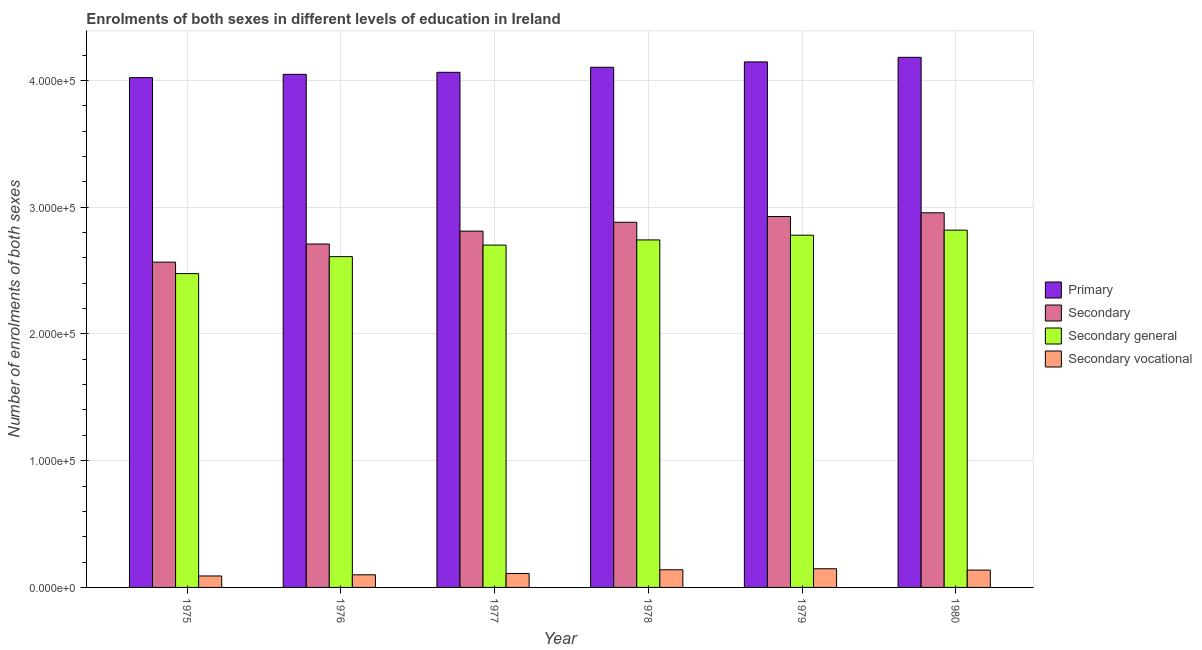Are the number of bars on each tick of the X-axis equal?
Your answer should be compact. Yes. How many bars are there on the 4th tick from the right?
Offer a very short reply. 4. What is the label of the 5th group of bars from the left?
Offer a terse response. 1979. What is the number of enrolments in secondary vocational education in 1976?
Your answer should be very brief. 9957. Across all years, what is the maximum number of enrolments in secondary general education?
Your answer should be very brief. 2.82e+05. Across all years, what is the minimum number of enrolments in secondary education?
Your response must be concise. 2.57e+05. In which year was the number of enrolments in secondary vocational education maximum?
Your answer should be compact. 1979. In which year was the number of enrolments in secondary vocational education minimum?
Give a very brief answer. 1975. What is the total number of enrolments in primary education in the graph?
Keep it short and to the point. 2.46e+06. What is the difference between the number of enrolments in secondary vocational education in 1976 and that in 1980?
Ensure brevity in your answer.  -3731. What is the difference between the number of enrolments in secondary general education in 1977 and the number of enrolments in secondary vocational education in 1980?
Make the answer very short. -1.18e+04. What is the average number of enrolments in secondary education per year?
Your answer should be compact. 2.81e+05. In how many years, is the number of enrolments in secondary general education greater than 40000?
Keep it short and to the point. 6. What is the ratio of the number of enrolments in secondary general education in 1975 to that in 1976?
Your response must be concise. 0.95. Is the number of enrolments in secondary education in 1976 less than that in 1978?
Make the answer very short. Yes. Is the difference between the number of enrolments in secondary education in 1978 and 1980 greater than the difference between the number of enrolments in secondary vocational education in 1978 and 1980?
Your answer should be compact. No. What is the difference between the highest and the second highest number of enrolments in secondary general education?
Your answer should be very brief. 3975. What is the difference between the highest and the lowest number of enrolments in secondary general education?
Make the answer very short. 3.43e+04. Is the sum of the number of enrolments in secondary education in 1975 and 1979 greater than the maximum number of enrolments in primary education across all years?
Provide a succinct answer. Yes. Is it the case that in every year, the sum of the number of enrolments in secondary vocational education and number of enrolments in primary education is greater than the sum of number of enrolments in secondary education and number of enrolments in secondary general education?
Provide a succinct answer. No. What does the 3rd bar from the left in 1980 represents?
Your response must be concise. Secondary general. What does the 4th bar from the right in 1980 represents?
Offer a terse response. Primary. Are all the bars in the graph horizontal?
Provide a short and direct response. No. What is the difference between two consecutive major ticks on the Y-axis?
Your answer should be very brief. 1.00e+05. Are the values on the major ticks of Y-axis written in scientific E-notation?
Offer a very short reply. Yes. Does the graph contain any zero values?
Keep it short and to the point. No. How are the legend labels stacked?
Keep it short and to the point. Vertical. What is the title of the graph?
Your answer should be very brief. Enrolments of both sexes in different levels of education in Ireland. What is the label or title of the Y-axis?
Keep it short and to the point. Number of enrolments of both sexes. What is the Number of enrolments of both sexes of Primary in 1975?
Give a very brief answer. 4.02e+05. What is the Number of enrolments of both sexes in Secondary in 1975?
Give a very brief answer. 2.57e+05. What is the Number of enrolments of both sexes of Secondary general in 1975?
Provide a succinct answer. 2.48e+05. What is the Number of enrolments of both sexes of Secondary vocational in 1975?
Your answer should be compact. 9043. What is the Number of enrolments of both sexes in Primary in 1976?
Ensure brevity in your answer.  4.05e+05. What is the Number of enrolments of both sexes in Secondary in 1976?
Keep it short and to the point. 2.71e+05. What is the Number of enrolments of both sexes in Secondary general in 1976?
Offer a very short reply. 2.61e+05. What is the Number of enrolments of both sexes in Secondary vocational in 1976?
Offer a very short reply. 9957. What is the Number of enrolments of both sexes of Primary in 1977?
Your answer should be very brief. 4.06e+05. What is the Number of enrolments of both sexes in Secondary in 1977?
Provide a succinct answer. 2.81e+05. What is the Number of enrolments of both sexes of Secondary general in 1977?
Your answer should be very brief. 2.70e+05. What is the Number of enrolments of both sexes in Secondary vocational in 1977?
Give a very brief answer. 1.10e+04. What is the Number of enrolments of both sexes of Primary in 1978?
Offer a terse response. 4.10e+05. What is the Number of enrolments of both sexes of Secondary in 1978?
Offer a terse response. 2.88e+05. What is the Number of enrolments of both sexes in Secondary general in 1978?
Make the answer very short. 2.74e+05. What is the Number of enrolments of both sexes of Secondary vocational in 1978?
Give a very brief answer. 1.39e+04. What is the Number of enrolments of both sexes of Primary in 1979?
Ensure brevity in your answer.  4.15e+05. What is the Number of enrolments of both sexes in Secondary in 1979?
Ensure brevity in your answer.  2.93e+05. What is the Number of enrolments of both sexes in Secondary general in 1979?
Offer a terse response. 2.78e+05. What is the Number of enrolments of both sexes of Secondary vocational in 1979?
Ensure brevity in your answer.  1.47e+04. What is the Number of enrolments of both sexes in Primary in 1980?
Offer a very short reply. 4.18e+05. What is the Number of enrolments of both sexes of Secondary in 1980?
Ensure brevity in your answer.  2.96e+05. What is the Number of enrolments of both sexes in Secondary general in 1980?
Your response must be concise. 2.82e+05. What is the Number of enrolments of both sexes in Secondary vocational in 1980?
Your response must be concise. 1.37e+04. Across all years, what is the maximum Number of enrolments of both sexes of Primary?
Your response must be concise. 4.18e+05. Across all years, what is the maximum Number of enrolments of both sexes in Secondary?
Give a very brief answer. 2.96e+05. Across all years, what is the maximum Number of enrolments of both sexes of Secondary general?
Give a very brief answer. 2.82e+05. Across all years, what is the maximum Number of enrolments of both sexes in Secondary vocational?
Ensure brevity in your answer.  1.47e+04. Across all years, what is the minimum Number of enrolments of both sexes in Primary?
Offer a very short reply. 4.02e+05. Across all years, what is the minimum Number of enrolments of both sexes of Secondary?
Provide a short and direct response. 2.57e+05. Across all years, what is the minimum Number of enrolments of both sexes in Secondary general?
Offer a terse response. 2.48e+05. Across all years, what is the minimum Number of enrolments of both sexes of Secondary vocational?
Your answer should be very brief. 9043. What is the total Number of enrolments of both sexes in Primary in the graph?
Your answer should be very brief. 2.46e+06. What is the total Number of enrolments of both sexes of Secondary in the graph?
Keep it short and to the point. 1.69e+06. What is the total Number of enrolments of both sexes of Secondary general in the graph?
Make the answer very short. 1.61e+06. What is the total Number of enrolments of both sexes in Secondary vocational in the graph?
Make the answer very short. 7.24e+04. What is the difference between the Number of enrolments of both sexes of Primary in 1975 and that in 1976?
Provide a short and direct response. -2599. What is the difference between the Number of enrolments of both sexes of Secondary in 1975 and that in 1976?
Provide a succinct answer. -1.43e+04. What is the difference between the Number of enrolments of both sexes in Secondary general in 1975 and that in 1976?
Keep it short and to the point. -1.34e+04. What is the difference between the Number of enrolments of both sexes of Secondary vocational in 1975 and that in 1976?
Offer a very short reply. -914. What is the difference between the Number of enrolments of both sexes of Primary in 1975 and that in 1977?
Your answer should be compact. -4213. What is the difference between the Number of enrolments of both sexes in Secondary in 1975 and that in 1977?
Provide a short and direct response. -2.45e+04. What is the difference between the Number of enrolments of both sexes of Secondary general in 1975 and that in 1977?
Keep it short and to the point. -2.25e+04. What is the difference between the Number of enrolments of both sexes in Secondary vocational in 1975 and that in 1977?
Provide a short and direct response. -1972. What is the difference between the Number of enrolments of both sexes of Primary in 1975 and that in 1978?
Make the answer very short. -8183. What is the difference between the Number of enrolments of both sexes of Secondary in 1975 and that in 1978?
Provide a short and direct response. -3.15e+04. What is the difference between the Number of enrolments of both sexes of Secondary general in 1975 and that in 1978?
Ensure brevity in your answer.  -2.66e+04. What is the difference between the Number of enrolments of both sexes in Secondary vocational in 1975 and that in 1978?
Your answer should be compact. -4879. What is the difference between the Number of enrolments of both sexes in Primary in 1975 and that in 1979?
Offer a very short reply. -1.24e+04. What is the difference between the Number of enrolments of both sexes in Secondary in 1975 and that in 1979?
Provide a short and direct response. -3.60e+04. What is the difference between the Number of enrolments of both sexes of Secondary general in 1975 and that in 1979?
Make the answer very short. -3.03e+04. What is the difference between the Number of enrolments of both sexes in Secondary vocational in 1975 and that in 1979?
Offer a terse response. -5686. What is the difference between the Number of enrolments of both sexes of Primary in 1975 and that in 1980?
Offer a very short reply. -1.60e+04. What is the difference between the Number of enrolments of both sexes in Secondary in 1975 and that in 1980?
Provide a succinct answer. -3.89e+04. What is the difference between the Number of enrolments of both sexes in Secondary general in 1975 and that in 1980?
Your answer should be compact. -3.43e+04. What is the difference between the Number of enrolments of both sexes in Secondary vocational in 1975 and that in 1980?
Ensure brevity in your answer.  -4645. What is the difference between the Number of enrolments of both sexes of Primary in 1976 and that in 1977?
Your answer should be very brief. -1614. What is the difference between the Number of enrolments of both sexes of Secondary in 1976 and that in 1977?
Provide a short and direct response. -1.02e+04. What is the difference between the Number of enrolments of both sexes in Secondary general in 1976 and that in 1977?
Give a very brief answer. -9107. What is the difference between the Number of enrolments of both sexes in Secondary vocational in 1976 and that in 1977?
Your answer should be compact. -1058. What is the difference between the Number of enrolments of both sexes in Primary in 1976 and that in 1978?
Your answer should be very brief. -5584. What is the difference between the Number of enrolments of both sexes in Secondary in 1976 and that in 1978?
Make the answer very short. -1.72e+04. What is the difference between the Number of enrolments of both sexes in Secondary general in 1976 and that in 1978?
Keep it short and to the point. -1.32e+04. What is the difference between the Number of enrolments of both sexes of Secondary vocational in 1976 and that in 1978?
Provide a short and direct response. -3965. What is the difference between the Number of enrolments of both sexes of Primary in 1976 and that in 1979?
Offer a very short reply. -9806. What is the difference between the Number of enrolments of both sexes in Secondary in 1976 and that in 1979?
Provide a succinct answer. -2.17e+04. What is the difference between the Number of enrolments of both sexes of Secondary general in 1976 and that in 1979?
Your answer should be very brief. -1.69e+04. What is the difference between the Number of enrolments of both sexes in Secondary vocational in 1976 and that in 1979?
Offer a terse response. -4772. What is the difference between the Number of enrolments of both sexes of Primary in 1976 and that in 1980?
Provide a succinct answer. -1.34e+04. What is the difference between the Number of enrolments of both sexes of Secondary in 1976 and that in 1980?
Provide a short and direct response. -2.46e+04. What is the difference between the Number of enrolments of both sexes of Secondary general in 1976 and that in 1980?
Your response must be concise. -2.09e+04. What is the difference between the Number of enrolments of both sexes of Secondary vocational in 1976 and that in 1980?
Your answer should be compact. -3731. What is the difference between the Number of enrolments of both sexes of Primary in 1977 and that in 1978?
Your response must be concise. -3970. What is the difference between the Number of enrolments of both sexes of Secondary in 1977 and that in 1978?
Offer a very short reply. -6989. What is the difference between the Number of enrolments of both sexes in Secondary general in 1977 and that in 1978?
Your answer should be compact. -4082. What is the difference between the Number of enrolments of both sexes of Secondary vocational in 1977 and that in 1978?
Ensure brevity in your answer.  -2907. What is the difference between the Number of enrolments of both sexes of Primary in 1977 and that in 1979?
Your answer should be compact. -8192. What is the difference between the Number of enrolments of both sexes of Secondary in 1977 and that in 1979?
Provide a succinct answer. -1.15e+04. What is the difference between the Number of enrolments of both sexes in Secondary general in 1977 and that in 1979?
Make the answer very short. -7823. What is the difference between the Number of enrolments of both sexes of Secondary vocational in 1977 and that in 1979?
Make the answer very short. -3714. What is the difference between the Number of enrolments of both sexes of Primary in 1977 and that in 1980?
Offer a terse response. -1.18e+04. What is the difference between the Number of enrolments of both sexes of Secondary in 1977 and that in 1980?
Keep it short and to the point. -1.45e+04. What is the difference between the Number of enrolments of both sexes of Secondary general in 1977 and that in 1980?
Your response must be concise. -1.18e+04. What is the difference between the Number of enrolments of both sexes in Secondary vocational in 1977 and that in 1980?
Provide a succinct answer. -2673. What is the difference between the Number of enrolments of both sexes of Primary in 1978 and that in 1979?
Ensure brevity in your answer.  -4222. What is the difference between the Number of enrolments of both sexes in Secondary in 1978 and that in 1979?
Make the answer very short. -4548. What is the difference between the Number of enrolments of both sexes of Secondary general in 1978 and that in 1979?
Your answer should be compact. -3741. What is the difference between the Number of enrolments of both sexes of Secondary vocational in 1978 and that in 1979?
Your response must be concise. -807. What is the difference between the Number of enrolments of both sexes in Primary in 1978 and that in 1980?
Offer a very short reply. -7845. What is the difference between the Number of enrolments of both sexes of Secondary in 1978 and that in 1980?
Provide a short and direct response. -7482. What is the difference between the Number of enrolments of both sexes in Secondary general in 1978 and that in 1980?
Offer a very short reply. -7716. What is the difference between the Number of enrolments of both sexes in Secondary vocational in 1978 and that in 1980?
Offer a terse response. 234. What is the difference between the Number of enrolments of both sexes of Primary in 1979 and that in 1980?
Offer a very short reply. -3623. What is the difference between the Number of enrolments of both sexes of Secondary in 1979 and that in 1980?
Your response must be concise. -2934. What is the difference between the Number of enrolments of both sexes in Secondary general in 1979 and that in 1980?
Keep it short and to the point. -3975. What is the difference between the Number of enrolments of both sexes in Secondary vocational in 1979 and that in 1980?
Provide a succinct answer. 1041. What is the difference between the Number of enrolments of both sexes in Primary in 1975 and the Number of enrolments of both sexes in Secondary in 1976?
Provide a succinct answer. 1.31e+05. What is the difference between the Number of enrolments of both sexes of Primary in 1975 and the Number of enrolments of both sexes of Secondary general in 1976?
Your answer should be compact. 1.41e+05. What is the difference between the Number of enrolments of both sexes of Primary in 1975 and the Number of enrolments of both sexes of Secondary vocational in 1976?
Your answer should be very brief. 3.92e+05. What is the difference between the Number of enrolments of both sexes of Secondary in 1975 and the Number of enrolments of both sexes of Secondary general in 1976?
Give a very brief answer. -4347. What is the difference between the Number of enrolments of both sexes in Secondary in 1975 and the Number of enrolments of both sexes in Secondary vocational in 1976?
Provide a short and direct response. 2.47e+05. What is the difference between the Number of enrolments of both sexes of Secondary general in 1975 and the Number of enrolments of both sexes of Secondary vocational in 1976?
Ensure brevity in your answer.  2.38e+05. What is the difference between the Number of enrolments of both sexes in Primary in 1975 and the Number of enrolments of both sexes in Secondary in 1977?
Give a very brief answer. 1.21e+05. What is the difference between the Number of enrolments of both sexes of Primary in 1975 and the Number of enrolments of both sexes of Secondary general in 1977?
Ensure brevity in your answer.  1.32e+05. What is the difference between the Number of enrolments of both sexes of Primary in 1975 and the Number of enrolments of both sexes of Secondary vocational in 1977?
Ensure brevity in your answer.  3.91e+05. What is the difference between the Number of enrolments of both sexes in Secondary in 1975 and the Number of enrolments of both sexes in Secondary general in 1977?
Give a very brief answer. -1.35e+04. What is the difference between the Number of enrolments of both sexes of Secondary in 1975 and the Number of enrolments of both sexes of Secondary vocational in 1977?
Your answer should be compact. 2.46e+05. What is the difference between the Number of enrolments of both sexes of Secondary general in 1975 and the Number of enrolments of both sexes of Secondary vocational in 1977?
Your answer should be very brief. 2.37e+05. What is the difference between the Number of enrolments of both sexes in Primary in 1975 and the Number of enrolments of both sexes in Secondary in 1978?
Give a very brief answer. 1.14e+05. What is the difference between the Number of enrolments of both sexes of Primary in 1975 and the Number of enrolments of both sexes of Secondary general in 1978?
Give a very brief answer. 1.28e+05. What is the difference between the Number of enrolments of both sexes of Primary in 1975 and the Number of enrolments of both sexes of Secondary vocational in 1978?
Make the answer very short. 3.88e+05. What is the difference between the Number of enrolments of both sexes of Secondary in 1975 and the Number of enrolments of both sexes of Secondary general in 1978?
Give a very brief answer. -1.75e+04. What is the difference between the Number of enrolments of both sexes of Secondary in 1975 and the Number of enrolments of both sexes of Secondary vocational in 1978?
Provide a succinct answer. 2.43e+05. What is the difference between the Number of enrolments of both sexes of Secondary general in 1975 and the Number of enrolments of both sexes of Secondary vocational in 1978?
Provide a succinct answer. 2.34e+05. What is the difference between the Number of enrolments of both sexes in Primary in 1975 and the Number of enrolments of both sexes in Secondary in 1979?
Your answer should be very brief. 1.10e+05. What is the difference between the Number of enrolments of both sexes of Primary in 1975 and the Number of enrolments of both sexes of Secondary general in 1979?
Your response must be concise. 1.24e+05. What is the difference between the Number of enrolments of both sexes of Primary in 1975 and the Number of enrolments of both sexes of Secondary vocational in 1979?
Provide a short and direct response. 3.87e+05. What is the difference between the Number of enrolments of both sexes of Secondary in 1975 and the Number of enrolments of both sexes of Secondary general in 1979?
Offer a terse response. -2.13e+04. What is the difference between the Number of enrolments of both sexes in Secondary in 1975 and the Number of enrolments of both sexes in Secondary vocational in 1979?
Provide a short and direct response. 2.42e+05. What is the difference between the Number of enrolments of both sexes in Secondary general in 1975 and the Number of enrolments of both sexes in Secondary vocational in 1979?
Ensure brevity in your answer.  2.33e+05. What is the difference between the Number of enrolments of both sexes of Primary in 1975 and the Number of enrolments of both sexes of Secondary in 1980?
Offer a terse response. 1.07e+05. What is the difference between the Number of enrolments of both sexes of Primary in 1975 and the Number of enrolments of both sexes of Secondary general in 1980?
Offer a terse response. 1.20e+05. What is the difference between the Number of enrolments of both sexes of Primary in 1975 and the Number of enrolments of both sexes of Secondary vocational in 1980?
Make the answer very short. 3.89e+05. What is the difference between the Number of enrolments of both sexes in Secondary in 1975 and the Number of enrolments of both sexes in Secondary general in 1980?
Ensure brevity in your answer.  -2.53e+04. What is the difference between the Number of enrolments of both sexes of Secondary in 1975 and the Number of enrolments of both sexes of Secondary vocational in 1980?
Keep it short and to the point. 2.43e+05. What is the difference between the Number of enrolments of both sexes in Secondary general in 1975 and the Number of enrolments of both sexes in Secondary vocational in 1980?
Provide a succinct answer. 2.34e+05. What is the difference between the Number of enrolments of both sexes of Primary in 1976 and the Number of enrolments of both sexes of Secondary in 1977?
Give a very brief answer. 1.24e+05. What is the difference between the Number of enrolments of both sexes in Primary in 1976 and the Number of enrolments of both sexes in Secondary general in 1977?
Offer a terse response. 1.35e+05. What is the difference between the Number of enrolments of both sexes in Primary in 1976 and the Number of enrolments of both sexes in Secondary vocational in 1977?
Keep it short and to the point. 3.94e+05. What is the difference between the Number of enrolments of both sexes of Secondary in 1976 and the Number of enrolments of both sexes of Secondary general in 1977?
Your answer should be very brief. 850. What is the difference between the Number of enrolments of both sexes of Secondary in 1976 and the Number of enrolments of both sexes of Secondary vocational in 1977?
Provide a short and direct response. 2.60e+05. What is the difference between the Number of enrolments of both sexes of Secondary general in 1976 and the Number of enrolments of both sexes of Secondary vocational in 1977?
Your answer should be very brief. 2.50e+05. What is the difference between the Number of enrolments of both sexes of Primary in 1976 and the Number of enrolments of both sexes of Secondary in 1978?
Your answer should be compact. 1.17e+05. What is the difference between the Number of enrolments of both sexes in Primary in 1976 and the Number of enrolments of both sexes in Secondary general in 1978?
Provide a short and direct response. 1.31e+05. What is the difference between the Number of enrolments of both sexes in Primary in 1976 and the Number of enrolments of both sexes in Secondary vocational in 1978?
Offer a terse response. 3.91e+05. What is the difference between the Number of enrolments of both sexes of Secondary in 1976 and the Number of enrolments of both sexes of Secondary general in 1978?
Your response must be concise. -3232. What is the difference between the Number of enrolments of both sexes of Secondary in 1976 and the Number of enrolments of both sexes of Secondary vocational in 1978?
Offer a terse response. 2.57e+05. What is the difference between the Number of enrolments of both sexes in Secondary general in 1976 and the Number of enrolments of both sexes in Secondary vocational in 1978?
Provide a succinct answer. 2.47e+05. What is the difference between the Number of enrolments of both sexes of Primary in 1976 and the Number of enrolments of both sexes of Secondary in 1979?
Ensure brevity in your answer.  1.12e+05. What is the difference between the Number of enrolments of both sexes in Primary in 1976 and the Number of enrolments of both sexes in Secondary general in 1979?
Your answer should be compact. 1.27e+05. What is the difference between the Number of enrolments of both sexes of Primary in 1976 and the Number of enrolments of both sexes of Secondary vocational in 1979?
Offer a very short reply. 3.90e+05. What is the difference between the Number of enrolments of both sexes of Secondary in 1976 and the Number of enrolments of both sexes of Secondary general in 1979?
Give a very brief answer. -6973. What is the difference between the Number of enrolments of both sexes in Secondary in 1976 and the Number of enrolments of both sexes in Secondary vocational in 1979?
Your answer should be very brief. 2.56e+05. What is the difference between the Number of enrolments of both sexes in Secondary general in 1976 and the Number of enrolments of both sexes in Secondary vocational in 1979?
Your answer should be compact. 2.46e+05. What is the difference between the Number of enrolments of both sexes in Primary in 1976 and the Number of enrolments of both sexes in Secondary in 1980?
Your answer should be compact. 1.09e+05. What is the difference between the Number of enrolments of both sexes of Primary in 1976 and the Number of enrolments of both sexes of Secondary general in 1980?
Offer a very short reply. 1.23e+05. What is the difference between the Number of enrolments of both sexes of Primary in 1976 and the Number of enrolments of both sexes of Secondary vocational in 1980?
Offer a terse response. 3.91e+05. What is the difference between the Number of enrolments of both sexes of Secondary in 1976 and the Number of enrolments of both sexes of Secondary general in 1980?
Keep it short and to the point. -1.09e+04. What is the difference between the Number of enrolments of both sexes of Secondary in 1976 and the Number of enrolments of both sexes of Secondary vocational in 1980?
Your answer should be very brief. 2.57e+05. What is the difference between the Number of enrolments of both sexes of Secondary general in 1976 and the Number of enrolments of both sexes of Secondary vocational in 1980?
Offer a very short reply. 2.47e+05. What is the difference between the Number of enrolments of both sexes of Primary in 1977 and the Number of enrolments of both sexes of Secondary in 1978?
Provide a succinct answer. 1.18e+05. What is the difference between the Number of enrolments of both sexes of Primary in 1977 and the Number of enrolments of both sexes of Secondary general in 1978?
Make the answer very short. 1.32e+05. What is the difference between the Number of enrolments of both sexes of Primary in 1977 and the Number of enrolments of both sexes of Secondary vocational in 1978?
Offer a terse response. 3.93e+05. What is the difference between the Number of enrolments of both sexes of Secondary in 1977 and the Number of enrolments of both sexes of Secondary general in 1978?
Keep it short and to the point. 6933. What is the difference between the Number of enrolments of both sexes in Secondary in 1977 and the Number of enrolments of both sexes in Secondary vocational in 1978?
Your response must be concise. 2.67e+05. What is the difference between the Number of enrolments of both sexes in Secondary general in 1977 and the Number of enrolments of both sexes in Secondary vocational in 1978?
Your response must be concise. 2.56e+05. What is the difference between the Number of enrolments of both sexes in Primary in 1977 and the Number of enrolments of both sexes in Secondary in 1979?
Keep it short and to the point. 1.14e+05. What is the difference between the Number of enrolments of both sexes in Primary in 1977 and the Number of enrolments of both sexes in Secondary general in 1979?
Ensure brevity in your answer.  1.29e+05. What is the difference between the Number of enrolments of both sexes of Primary in 1977 and the Number of enrolments of both sexes of Secondary vocational in 1979?
Your answer should be very brief. 3.92e+05. What is the difference between the Number of enrolments of both sexes in Secondary in 1977 and the Number of enrolments of both sexes in Secondary general in 1979?
Your response must be concise. 3192. What is the difference between the Number of enrolments of both sexes in Secondary in 1977 and the Number of enrolments of both sexes in Secondary vocational in 1979?
Offer a terse response. 2.66e+05. What is the difference between the Number of enrolments of both sexes of Secondary general in 1977 and the Number of enrolments of both sexes of Secondary vocational in 1979?
Provide a short and direct response. 2.55e+05. What is the difference between the Number of enrolments of both sexes of Primary in 1977 and the Number of enrolments of both sexes of Secondary in 1980?
Offer a terse response. 1.11e+05. What is the difference between the Number of enrolments of both sexes in Primary in 1977 and the Number of enrolments of both sexes in Secondary general in 1980?
Your answer should be compact. 1.25e+05. What is the difference between the Number of enrolments of both sexes of Primary in 1977 and the Number of enrolments of both sexes of Secondary vocational in 1980?
Make the answer very short. 3.93e+05. What is the difference between the Number of enrolments of both sexes in Secondary in 1977 and the Number of enrolments of both sexes in Secondary general in 1980?
Offer a very short reply. -783. What is the difference between the Number of enrolments of both sexes in Secondary in 1977 and the Number of enrolments of both sexes in Secondary vocational in 1980?
Make the answer very short. 2.67e+05. What is the difference between the Number of enrolments of both sexes of Secondary general in 1977 and the Number of enrolments of both sexes of Secondary vocational in 1980?
Offer a terse response. 2.56e+05. What is the difference between the Number of enrolments of both sexes in Primary in 1978 and the Number of enrolments of both sexes in Secondary in 1979?
Make the answer very short. 1.18e+05. What is the difference between the Number of enrolments of both sexes of Primary in 1978 and the Number of enrolments of both sexes of Secondary general in 1979?
Your answer should be very brief. 1.32e+05. What is the difference between the Number of enrolments of both sexes of Primary in 1978 and the Number of enrolments of both sexes of Secondary vocational in 1979?
Provide a short and direct response. 3.96e+05. What is the difference between the Number of enrolments of both sexes of Secondary in 1978 and the Number of enrolments of both sexes of Secondary general in 1979?
Keep it short and to the point. 1.02e+04. What is the difference between the Number of enrolments of both sexes of Secondary in 1978 and the Number of enrolments of both sexes of Secondary vocational in 1979?
Your answer should be very brief. 2.73e+05. What is the difference between the Number of enrolments of both sexes in Secondary general in 1978 and the Number of enrolments of both sexes in Secondary vocational in 1979?
Your response must be concise. 2.59e+05. What is the difference between the Number of enrolments of both sexes in Primary in 1978 and the Number of enrolments of both sexes in Secondary in 1980?
Your answer should be very brief. 1.15e+05. What is the difference between the Number of enrolments of both sexes of Primary in 1978 and the Number of enrolments of both sexes of Secondary general in 1980?
Give a very brief answer. 1.28e+05. What is the difference between the Number of enrolments of both sexes of Primary in 1978 and the Number of enrolments of both sexes of Secondary vocational in 1980?
Keep it short and to the point. 3.97e+05. What is the difference between the Number of enrolments of both sexes in Secondary in 1978 and the Number of enrolments of both sexes in Secondary general in 1980?
Make the answer very short. 6206. What is the difference between the Number of enrolments of both sexes of Secondary in 1978 and the Number of enrolments of both sexes of Secondary vocational in 1980?
Provide a succinct answer. 2.74e+05. What is the difference between the Number of enrolments of both sexes of Secondary general in 1978 and the Number of enrolments of both sexes of Secondary vocational in 1980?
Your response must be concise. 2.60e+05. What is the difference between the Number of enrolments of both sexes in Primary in 1979 and the Number of enrolments of both sexes in Secondary in 1980?
Make the answer very short. 1.19e+05. What is the difference between the Number of enrolments of both sexes in Primary in 1979 and the Number of enrolments of both sexes in Secondary general in 1980?
Offer a very short reply. 1.33e+05. What is the difference between the Number of enrolments of both sexes in Primary in 1979 and the Number of enrolments of both sexes in Secondary vocational in 1980?
Your answer should be very brief. 4.01e+05. What is the difference between the Number of enrolments of both sexes in Secondary in 1979 and the Number of enrolments of both sexes in Secondary general in 1980?
Make the answer very short. 1.08e+04. What is the difference between the Number of enrolments of both sexes of Secondary in 1979 and the Number of enrolments of both sexes of Secondary vocational in 1980?
Your answer should be compact. 2.79e+05. What is the difference between the Number of enrolments of both sexes of Secondary general in 1979 and the Number of enrolments of both sexes of Secondary vocational in 1980?
Give a very brief answer. 2.64e+05. What is the average Number of enrolments of both sexes of Primary per year?
Keep it short and to the point. 4.09e+05. What is the average Number of enrolments of both sexes of Secondary per year?
Provide a succinct answer. 2.81e+05. What is the average Number of enrolments of both sexes in Secondary general per year?
Offer a very short reply. 2.69e+05. What is the average Number of enrolments of both sexes in Secondary vocational per year?
Provide a succinct answer. 1.21e+04. In the year 1975, what is the difference between the Number of enrolments of both sexes of Primary and Number of enrolments of both sexes of Secondary?
Your answer should be very brief. 1.46e+05. In the year 1975, what is the difference between the Number of enrolments of both sexes of Primary and Number of enrolments of both sexes of Secondary general?
Your answer should be very brief. 1.55e+05. In the year 1975, what is the difference between the Number of enrolments of both sexes of Primary and Number of enrolments of both sexes of Secondary vocational?
Ensure brevity in your answer.  3.93e+05. In the year 1975, what is the difference between the Number of enrolments of both sexes in Secondary and Number of enrolments of both sexes in Secondary general?
Your answer should be very brief. 9043. In the year 1975, what is the difference between the Number of enrolments of both sexes in Secondary and Number of enrolments of both sexes in Secondary vocational?
Your answer should be very brief. 2.48e+05. In the year 1975, what is the difference between the Number of enrolments of both sexes in Secondary general and Number of enrolments of both sexes in Secondary vocational?
Give a very brief answer. 2.39e+05. In the year 1976, what is the difference between the Number of enrolments of both sexes of Primary and Number of enrolments of both sexes of Secondary?
Ensure brevity in your answer.  1.34e+05. In the year 1976, what is the difference between the Number of enrolments of both sexes in Primary and Number of enrolments of both sexes in Secondary general?
Keep it short and to the point. 1.44e+05. In the year 1976, what is the difference between the Number of enrolments of both sexes in Primary and Number of enrolments of both sexes in Secondary vocational?
Offer a terse response. 3.95e+05. In the year 1976, what is the difference between the Number of enrolments of both sexes in Secondary and Number of enrolments of both sexes in Secondary general?
Your answer should be very brief. 9957. In the year 1976, what is the difference between the Number of enrolments of both sexes in Secondary and Number of enrolments of both sexes in Secondary vocational?
Your answer should be very brief. 2.61e+05. In the year 1976, what is the difference between the Number of enrolments of both sexes in Secondary general and Number of enrolments of both sexes in Secondary vocational?
Make the answer very short. 2.51e+05. In the year 1977, what is the difference between the Number of enrolments of both sexes in Primary and Number of enrolments of both sexes in Secondary?
Your answer should be very brief. 1.25e+05. In the year 1977, what is the difference between the Number of enrolments of both sexes of Primary and Number of enrolments of both sexes of Secondary general?
Your answer should be compact. 1.36e+05. In the year 1977, what is the difference between the Number of enrolments of both sexes in Primary and Number of enrolments of both sexes in Secondary vocational?
Your answer should be very brief. 3.95e+05. In the year 1977, what is the difference between the Number of enrolments of both sexes in Secondary and Number of enrolments of both sexes in Secondary general?
Your answer should be very brief. 1.10e+04. In the year 1977, what is the difference between the Number of enrolments of both sexes in Secondary and Number of enrolments of both sexes in Secondary vocational?
Provide a succinct answer. 2.70e+05. In the year 1977, what is the difference between the Number of enrolments of both sexes in Secondary general and Number of enrolments of both sexes in Secondary vocational?
Your answer should be compact. 2.59e+05. In the year 1978, what is the difference between the Number of enrolments of both sexes of Primary and Number of enrolments of both sexes of Secondary?
Provide a succinct answer. 1.22e+05. In the year 1978, what is the difference between the Number of enrolments of both sexes in Primary and Number of enrolments of both sexes in Secondary general?
Provide a short and direct response. 1.36e+05. In the year 1978, what is the difference between the Number of enrolments of both sexes of Primary and Number of enrolments of both sexes of Secondary vocational?
Offer a terse response. 3.96e+05. In the year 1978, what is the difference between the Number of enrolments of both sexes of Secondary and Number of enrolments of both sexes of Secondary general?
Make the answer very short. 1.39e+04. In the year 1978, what is the difference between the Number of enrolments of both sexes in Secondary and Number of enrolments of both sexes in Secondary vocational?
Your answer should be very brief. 2.74e+05. In the year 1978, what is the difference between the Number of enrolments of both sexes of Secondary general and Number of enrolments of both sexes of Secondary vocational?
Ensure brevity in your answer.  2.60e+05. In the year 1979, what is the difference between the Number of enrolments of both sexes in Primary and Number of enrolments of both sexes in Secondary?
Make the answer very short. 1.22e+05. In the year 1979, what is the difference between the Number of enrolments of both sexes in Primary and Number of enrolments of both sexes in Secondary general?
Provide a succinct answer. 1.37e+05. In the year 1979, what is the difference between the Number of enrolments of both sexes of Primary and Number of enrolments of both sexes of Secondary vocational?
Your answer should be very brief. 4.00e+05. In the year 1979, what is the difference between the Number of enrolments of both sexes of Secondary and Number of enrolments of both sexes of Secondary general?
Keep it short and to the point. 1.47e+04. In the year 1979, what is the difference between the Number of enrolments of both sexes in Secondary and Number of enrolments of both sexes in Secondary vocational?
Make the answer very short. 2.78e+05. In the year 1979, what is the difference between the Number of enrolments of both sexes in Secondary general and Number of enrolments of both sexes in Secondary vocational?
Provide a short and direct response. 2.63e+05. In the year 1980, what is the difference between the Number of enrolments of both sexes of Primary and Number of enrolments of both sexes of Secondary?
Ensure brevity in your answer.  1.23e+05. In the year 1980, what is the difference between the Number of enrolments of both sexes in Primary and Number of enrolments of both sexes in Secondary general?
Make the answer very short. 1.36e+05. In the year 1980, what is the difference between the Number of enrolments of both sexes in Primary and Number of enrolments of both sexes in Secondary vocational?
Your answer should be very brief. 4.05e+05. In the year 1980, what is the difference between the Number of enrolments of both sexes of Secondary and Number of enrolments of both sexes of Secondary general?
Your answer should be compact. 1.37e+04. In the year 1980, what is the difference between the Number of enrolments of both sexes of Secondary and Number of enrolments of both sexes of Secondary vocational?
Offer a terse response. 2.82e+05. In the year 1980, what is the difference between the Number of enrolments of both sexes in Secondary general and Number of enrolments of both sexes in Secondary vocational?
Provide a short and direct response. 2.68e+05. What is the ratio of the Number of enrolments of both sexes in Primary in 1975 to that in 1976?
Offer a very short reply. 0.99. What is the ratio of the Number of enrolments of both sexes of Secondary in 1975 to that in 1976?
Make the answer very short. 0.95. What is the ratio of the Number of enrolments of both sexes of Secondary general in 1975 to that in 1976?
Your response must be concise. 0.95. What is the ratio of the Number of enrolments of both sexes of Secondary vocational in 1975 to that in 1976?
Your response must be concise. 0.91. What is the ratio of the Number of enrolments of both sexes of Primary in 1975 to that in 1977?
Your answer should be compact. 0.99. What is the ratio of the Number of enrolments of both sexes of Secondary vocational in 1975 to that in 1977?
Provide a short and direct response. 0.82. What is the ratio of the Number of enrolments of both sexes in Primary in 1975 to that in 1978?
Provide a short and direct response. 0.98. What is the ratio of the Number of enrolments of both sexes of Secondary in 1975 to that in 1978?
Provide a short and direct response. 0.89. What is the ratio of the Number of enrolments of both sexes in Secondary general in 1975 to that in 1978?
Your answer should be compact. 0.9. What is the ratio of the Number of enrolments of both sexes of Secondary vocational in 1975 to that in 1978?
Your answer should be very brief. 0.65. What is the ratio of the Number of enrolments of both sexes in Primary in 1975 to that in 1979?
Offer a very short reply. 0.97. What is the ratio of the Number of enrolments of both sexes of Secondary in 1975 to that in 1979?
Provide a succinct answer. 0.88. What is the ratio of the Number of enrolments of both sexes in Secondary general in 1975 to that in 1979?
Your response must be concise. 0.89. What is the ratio of the Number of enrolments of both sexes of Secondary vocational in 1975 to that in 1979?
Your answer should be compact. 0.61. What is the ratio of the Number of enrolments of both sexes of Primary in 1975 to that in 1980?
Give a very brief answer. 0.96. What is the ratio of the Number of enrolments of both sexes in Secondary in 1975 to that in 1980?
Offer a terse response. 0.87. What is the ratio of the Number of enrolments of both sexes in Secondary general in 1975 to that in 1980?
Offer a very short reply. 0.88. What is the ratio of the Number of enrolments of both sexes of Secondary vocational in 1975 to that in 1980?
Provide a short and direct response. 0.66. What is the ratio of the Number of enrolments of both sexes in Primary in 1976 to that in 1977?
Ensure brevity in your answer.  1. What is the ratio of the Number of enrolments of both sexes of Secondary in 1976 to that in 1977?
Keep it short and to the point. 0.96. What is the ratio of the Number of enrolments of both sexes in Secondary general in 1976 to that in 1977?
Keep it short and to the point. 0.97. What is the ratio of the Number of enrolments of both sexes in Secondary vocational in 1976 to that in 1977?
Keep it short and to the point. 0.9. What is the ratio of the Number of enrolments of both sexes in Primary in 1976 to that in 1978?
Make the answer very short. 0.99. What is the ratio of the Number of enrolments of both sexes of Secondary in 1976 to that in 1978?
Your response must be concise. 0.94. What is the ratio of the Number of enrolments of both sexes in Secondary general in 1976 to that in 1978?
Provide a short and direct response. 0.95. What is the ratio of the Number of enrolments of both sexes of Secondary vocational in 1976 to that in 1978?
Make the answer very short. 0.72. What is the ratio of the Number of enrolments of both sexes in Primary in 1976 to that in 1979?
Your response must be concise. 0.98. What is the ratio of the Number of enrolments of both sexes in Secondary in 1976 to that in 1979?
Ensure brevity in your answer.  0.93. What is the ratio of the Number of enrolments of both sexes of Secondary general in 1976 to that in 1979?
Provide a succinct answer. 0.94. What is the ratio of the Number of enrolments of both sexes of Secondary vocational in 1976 to that in 1979?
Your response must be concise. 0.68. What is the ratio of the Number of enrolments of both sexes of Primary in 1976 to that in 1980?
Keep it short and to the point. 0.97. What is the ratio of the Number of enrolments of both sexes of Secondary in 1976 to that in 1980?
Offer a terse response. 0.92. What is the ratio of the Number of enrolments of both sexes in Secondary general in 1976 to that in 1980?
Ensure brevity in your answer.  0.93. What is the ratio of the Number of enrolments of both sexes in Secondary vocational in 1976 to that in 1980?
Provide a succinct answer. 0.73. What is the ratio of the Number of enrolments of both sexes of Primary in 1977 to that in 1978?
Offer a terse response. 0.99. What is the ratio of the Number of enrolments of both sexes of Secondary in 1977 to that in 1978?
Keep it short and to the point. 0.98. What is the ratio of the Number of enrolments of both sexes in Secondary general in 1977 to that in 1978?
Keep it short and to the point. 0.99. What is the ratio of the Number of enrolments of both sexes in Secondary vocational in 1977 to that in 1978?
Your answer should be compact. 0.79. What is the ratio of the Number of enrolments of both sexes of Primary in 1977 to that in 1979?
Keep it short and to the point. 0.98. What is the ratio of the Number of enrolments of both sexes in Secondary in 1977 to that in 1979?
Keep it short and to the point. 0.96. What is the ratio of the Number of enrolments of both sexes in Secondary general in 1977 to that in 1979?
Provide a succinct answer. 0.97. What is the ratio of the Number of enrolments of both sexes in Secondary vocational in 1977 to that in 1979?
Your response must be concise. 0.75. What is the ratio of the Number of enrolments of both sexes in Primary in 1977 to that in 1980?
Give a very brief answer. 0.97. What is the ratio of the Number of enrolments of both sexes in Secondary in 1977 to that in 1980?
Keep it short and to the point. 0.95. What is the ratio of the Number of enrolments of both sexes of Secondary general in 1977 to that in 1980?
Give a very brief answer. 0.96. What is the ratio of the Number of enrolments of both sexes of Secondary vocational in 1977 to that in 1980?
Your response must be concise. 0.8. What is the ratio of the Number of enrolments of both sexes in Primary in 1978 to that in 1979?
Give a very brief answer. 0.99. What is the ratio of the Number of enrolments of both sexes of Secondary in 1978 to that in 1979?
Give a very brief answer. 0.98. What is the ratio of the Number of enrolments of both sexes of Secondary general in 1978 to that in 1979?
Provide a succinct answer. 0.99. What is the ratio of the Number of enrolments of both sexes in Secondary vocational in 1978 to that in 1979?
Your answer should be very brief. 0.95. What is the ratio of the Number of enrolments of both sexes of Primary in 1978 to that in 1980?
Offer a terse response. 0.98. What is the ratio of the Number of enrolments of both sexes of Secondary in 1978 to that in 1980?
Provide a succinct answer. 0.97. What is the ratio of the Number of enrolments of both sexes in Secondary general in 1978 to that in 1980?
Provide a short and direct response. 0.97. What is the ratio of the Number of enrolments of both sexes of Secondary vocational in 1978 to that in 1980?
Your response must be concise. 1.02. What is the ratio of the Number of enrolments of both sexes in Secondary in 1979 to that in 1980?
Offer a very short reply. 0.99. What is the ratio of the Number of enrolments of both sexes of Secondary general in 1979 to that in 1980?
Your answer should be compact. 0.99. What is the ratio of the Number of enrolments of both sexes in Secondary vocational in 1979 to that in 1980?
Offer a terse response. 1.08. What is the difference between the highest and the second highest Number of enrolments of both sexes in Primary?
Keep it short and to the point. 3623. What is the difference between the highest and the second highest Number of enrolments of both sexes in Secondary?
Provide a short and direct response. 2934. What is the difference between the highest and the second highest Number of enrolments of both sexes of Secondary general?
Offer a terse response. 3975. What is the difference between the highest and the second highest Number of enrolments of both sexes of Secondary vocational?
Your response must be concise. 807. What is the difference between the highest and the lowest Number of enrolments of both sexes in Primary?
Ensure brevity in your answer.  1.60e+04. What is the difference between the highest and the lowest Number of enrolments of both sexes of Secondary?
Make the answer very short. 3.89e+04. What is the difference between the highest and the lowest Number of enrolments of both sexes of Secondary general?
Give a very brief answer. 3.43e+04. What is the difference between the highest and the lowest Number of enrolments of both sexes in Secondary vocational?
Keep it short and to the point. 5686. 